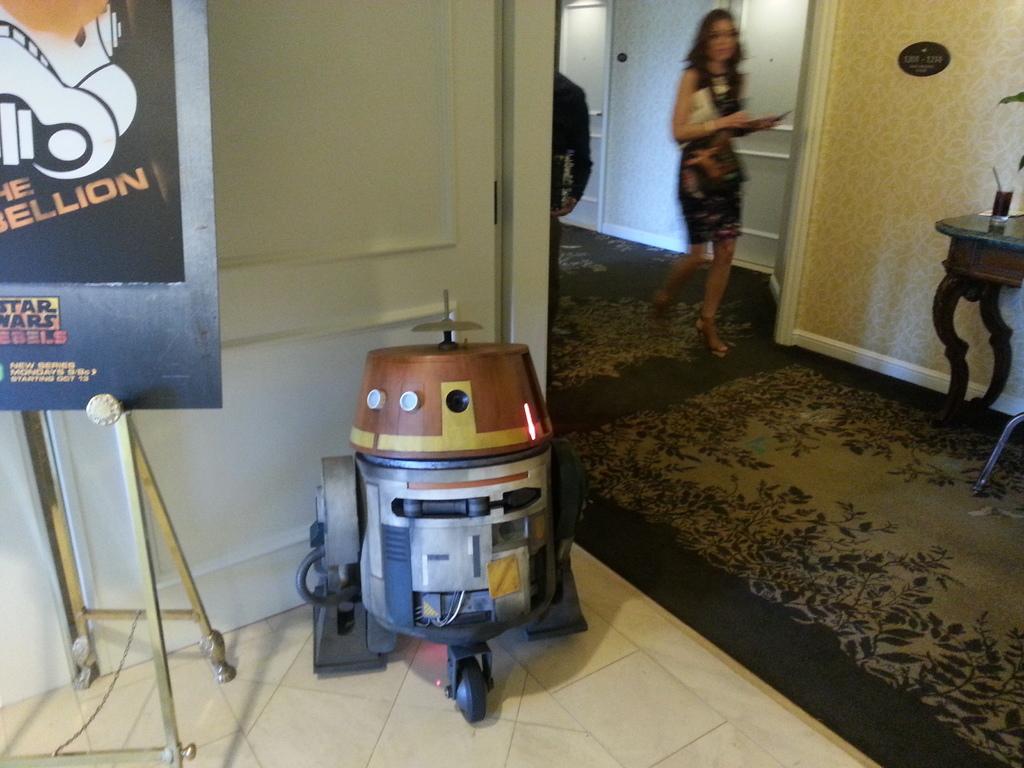Which movie is featured on the poster?
Your response must be concise. Star wars. What kind of star wars movie is featured?
Ensure brevity in your answer.  Rebels. 